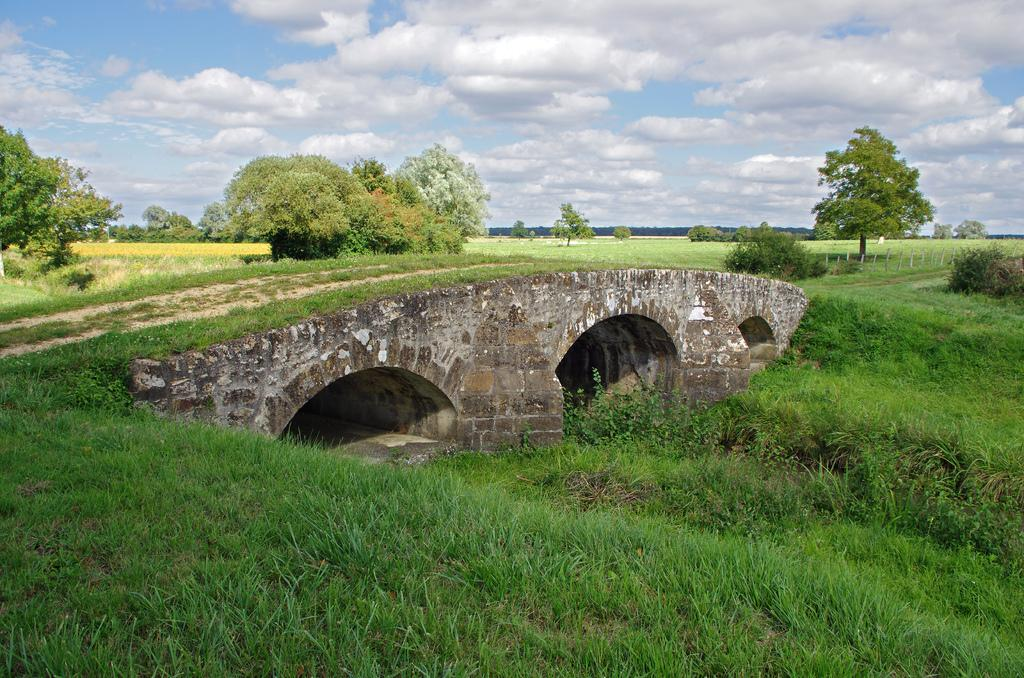What type of vegetation can be seen in the image? There is grass in the image. What color is the grass? The grass is green. What other natural elements are present in the image? There are trees in the image. What color are the trees? The trees are green. What can be seen above the grass and trees in the image? The sky is visible in the image. What colors are present in the sky? The sky is blue and white. Can you tell me how many boys are enjoying pleasure in the image? There are no boys or any indication of pleasure in the image; it features green grass, trees, and a blue and white sky. Is there a beggar visible in the image? There is no beggar present in the image; it features green grass, trees, and a blue and white sky. 